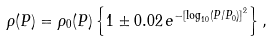Convert formula to latex. <formula><loc_0><loc_0><loc_500><loc_500>\rho ( P ) = \rho _ { 0 } ( P ) \left \{ 1 \pm 0 . 0 2 \, e ^ { - \left [ \log _ { 1 0 } ( P / P _ { 0 } ) \right ] ^ { 2 } } \right \} ,</formula> 